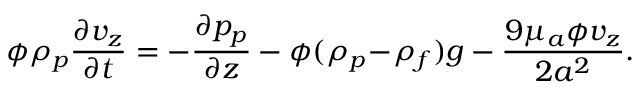Convert formula to latex. <formula><loc_0><loc_0><loc_500><loc_500>\phi \rho _ { p } \frac { \partial v _ { z } } { \partial t } = - \frac { \partial p _ { p } } { \partial z } - \phi ( \rho _ { p } \, - \, \rho _ { f } ) g - \frac { 9 \mu _ { a } \phi v _ { z } } { 2 a ^ { 2 } } .</formula> 